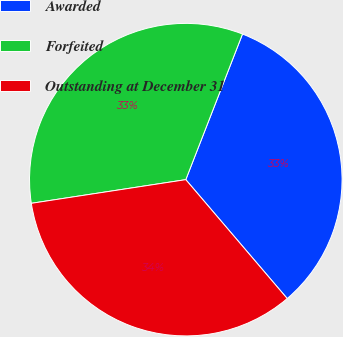<chart> <loc_0><loc_0><loc_500><loc_500><pie_chart><fcel>Awarded<fcel>Forfeited<fcel>Outstanding at December 31<nl><fcel>32.85%<fcel>33.33%<fcel>33.82%<nl></chart> 